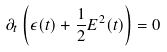<formula> <loc_0><loc_0><loc_500><loc_500>\partial _ { t } \left ( \epsilon ( t ) + \frac { 1 } { 2 } E ^ { 2 } ( t ) \right ) = 0</formula> 